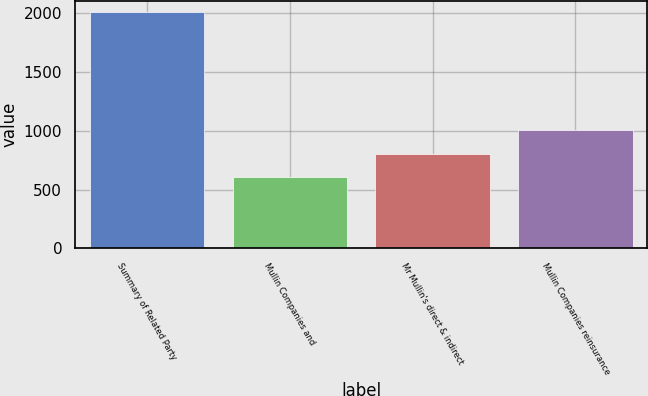<chart> <loc_0><loc_0><loc_500><loc_500><bar_chart><fcel>Summary of Related Party<fcel>Mullin Companies and<fcel>Mr Mullin's direct & indirect<fcel>Mullin Companies reinsurance<nl><fcel>2007<fcel>602.17<fcel>802.86<fcel>1003.55<nl></chart> 